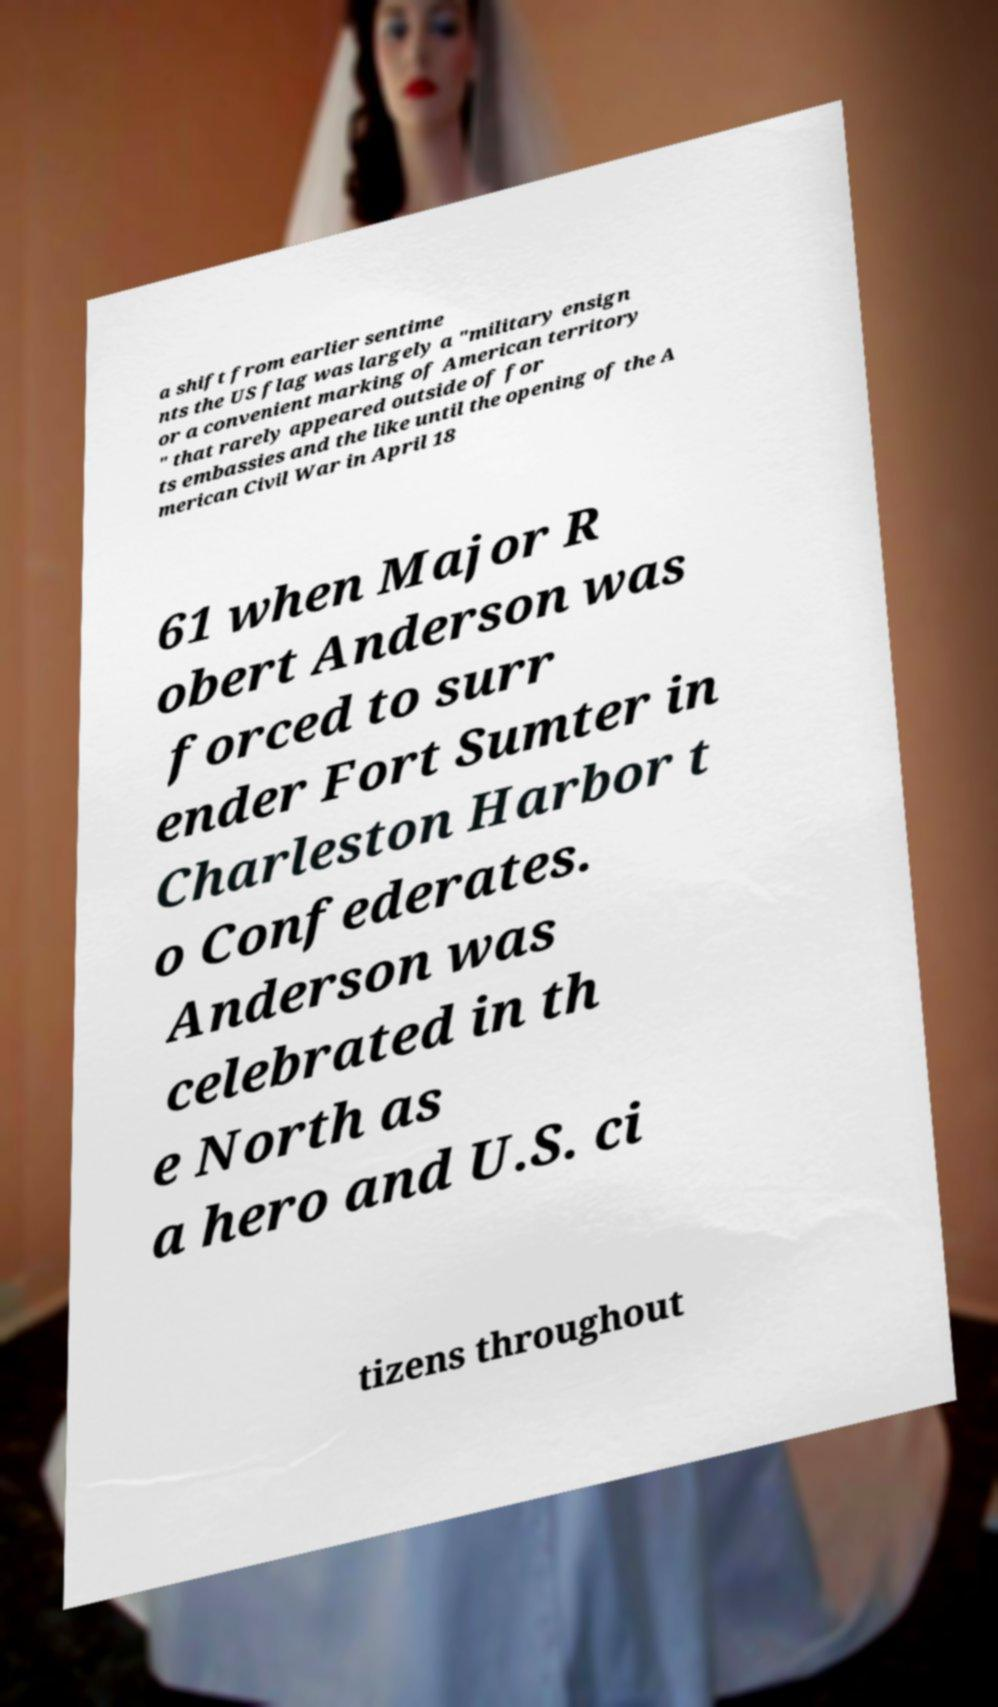Could you extract and type out the text from this image? a shift from earlier sentime nts the US flag was largely a "military ensign or a convenient marking of American territory " that rarely appeared outside of for ts embassies and the like until the opening of the A merican Civil War in April 18 61 when Major R obert Anderson was forced to surr ender Fort Sumter in Charleston Harbor t o Confederates. Anderson was celebrated in th e North as a hero and U.S. ci tizens throughout 